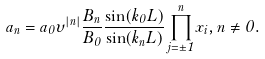<formula> <loc_0><loc_0><loc_500><loc_500>a _ { n } = a _ { 0 } \upsilon ^ { | n | } \frac { B _ { n } } { B _ { 0 } } \frac { \sin ( k _ { 0 } L ) } { \sin ( k _ { n } L ) } \prod _ { j = \pm 1 } ^ { n } x _ { i } , n \neq 0 .</formula> 